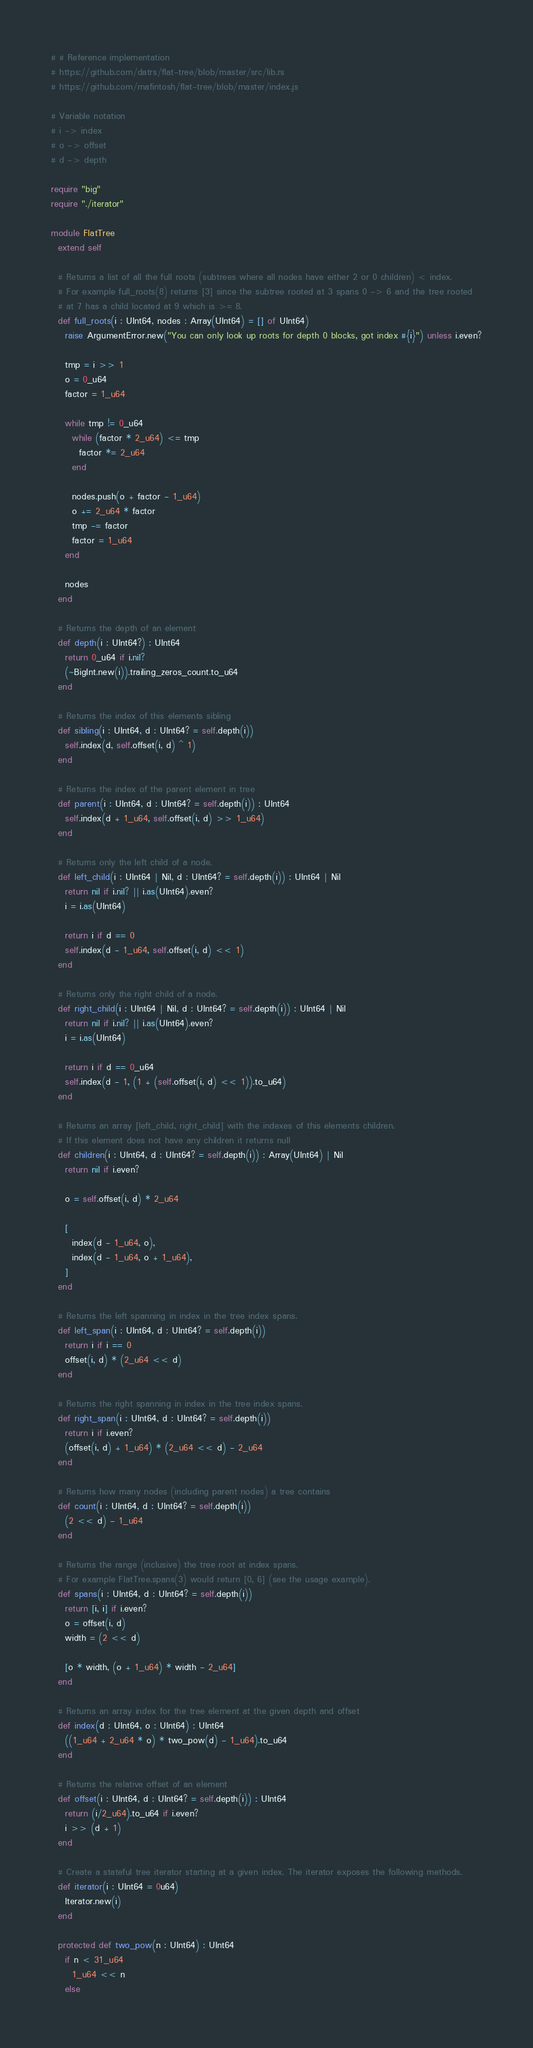Convert code to text. <code><loc_0><loc_0><loc_500><loc_500><_Crystal_># # Reference implementation
# https://github.com/datrs/flat-tree/blob/master/src/lib.rs
# https://github.com/mafintosh/flat-tree/blob/master/index.js

# Variable notation
# i -> index
# o -> offset
# d -> depth

require "big"
require "./iterator"

module FlatTree
  extend self

  # Returns a list of all the full roots (subtrees where all nodes have either 2 or 0 children) < index.
  # For example full_roots(8) returns [3] since the subtree rooted at 3 spans 0 -> 6 and the tree rooted
  # at 7 has a child located at 9 which is >= 8.
  def full_roots(i : UInt64, nodes : Array(UInt64) = [] of UInt64)
    raise ArgumentError.new("You can only look up roots for depth 0 blocks, got index #{i}") unless i.even?

    tmp = i >> 1
    o = 0_u64
    factor = 1_u64

    while tmp != 0_u64
      while (factor * 2_u64) <= tmp
        factor *= 2_u64
      end

      nodes.push(o + factor - 1_u64)
      o += 2_u64 * factor
      tmp -= factor
      factor = 1_u64
    end

    nodes
  end

  # Returns the depth of an element
  def depth(i : UInt64?) : UInt64
    return 0_u64 if i.nil?
    (~BigInt.new(i)).trailing_zeros_count.to_u64
  end

  # Returns the index of this elements sibling
  def sibling(i : UInt64, d : UInt64? = self.depth(i))
    self.index(d, self.offset(i, d) ^ 1)
  end

  # Returns the index of the parent element in tree
  def parent(i : UInt64, d : UInt64? = self.depth(i)) : UInt64
    self.index(d + 1_u64, self.offset(i, d) >> 1_u64)
  end

  # Returns only the left child of a node.
  def left_child(i : UInt64 | Nil, d : UInt64? = self.depth(i)) : UInt64 | Nil
    return nil if i.nil? || i.as(UInt64).even?
    i = i.as(UInt64)

    return i if d == 0
    self.index(d - 1_u64, self.offset(i, d) << 1)
  end

  # Returns only the right child of a node.
  def right_child(i : UInt64 | Nil, d : UInt64? = self.depth(i)) : UInt64 | Nil
    return nil if i.nil? || i.as(UInt64).even?
    i = i.as(UInt64)

    return i if d == 0_u64
    self.index(d - 1, (1 + (self.offset(i, d) << 1)).to_u64)
  end

  # Returns an array [left_child, right_child] with the indexes of this elements children.
  # If this element does not have any children it returns null
  def children(i : UInt64, d : UInt64? = self.depth(i)) : Array(UInt64) | Nil
    return nil if i.even?

    o = self.offset(i, d) * 2_u64

    [
      index(d - 1_u64, o),
      index(d - 1_u64, o + 1_u64),
    ]
  end

  # Returns the left spanning in index in the tree index spans.
  def left_span(i : UInt64, d : UInt64? = self.depth(i))
    return i if i == 0
    offset(i, d) * (2_u64 << d)
  end

  # Returns the right spanning in index in the tree index spans.
  def right_span(i : UInt64, d : UInt64? = self.depth(i))
    return i if i.even?
    (offset(i, d) + 1_u64) * (2_u64 << d) - 2_u64
  end

  # Returns how many nodes (including parent nodes) a tree contains
  def count(i : UInt64, d : UInt64? = self.depth(i))
    (2 << d) - 1_u64
  end

  # Returns the range (inclusive) the tree root at index spans.
  # For example FlatTree.spans(3) would return [0, 6] (see the usage example).
  def spans(i : UInt64, d : UInt64? = self.depth(i))
    return [i, i] if i.even?
    o = offset(i, d)
    width = (2 << d)

    [o * width, (o + 1_u64) * width - 2_u64]
  end

  # Returns an array index for the tree element at the given depth and offset
  def index(d : UInt64, o : UInt64) : UInt64
    ((1_u64 + 2_u64 * o) * two_pow(d) - 1_u64).to_u64
  end

  # Returns the relative offset of an element
  def offset(i : UInt64, d : UInt64? = self.depth(i)) : UInt64
    return (i/2_u64).to_u64 if i.even?
    i >> (d + 1)
  end

  # Create a stateful tree iterator starting at a given index. The iterator exposes the following methods.
  def iterator(i : UInt64 = 0u64)
    Iterator.new(i)
  end

  protected def two_pow(n : UInt64) : UInt64
    if n < 31_u64
      1_u64 << n
    else</code> 